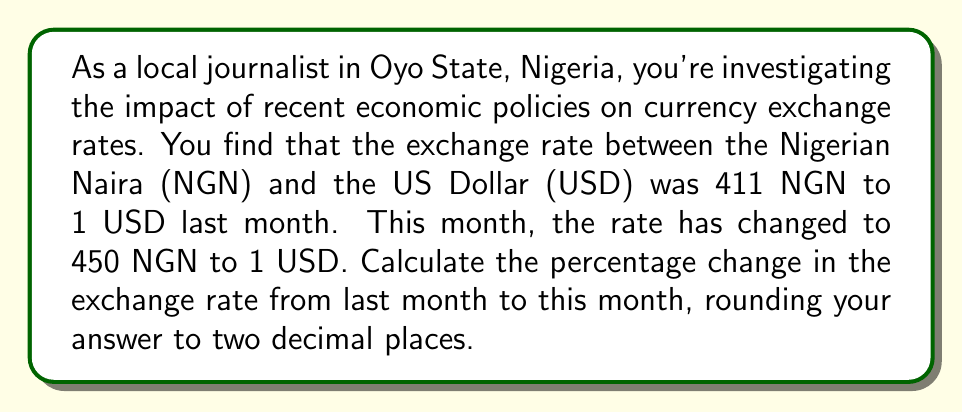Provide a solution to this math problem. To calculate the percentage change in the exchange rate, we need to follow these steps:

1. Identify the initial and final values:
   Initial value (last month): 411 NGN/USD
   Final value (this month): 450 NGN/USD

2. Calculate the difference between the final and initial values:
   $\text{Difference} = \text{Final value} - \text{Initial value}$
   $\text{Difference} = 450 - 411 = 39$

3. Divide the difference by the initial value:
   $\frac{\text{Difference}}{\text{Initial value}} = \frac{39}{411} \approx 0.0948905109$

4. Multiply the result by 100 to express it as a percentage:
   $0.0948905109 \times 100 \approx 9.48905109\%$

5. Round the result to two decimal places:
   $9.49\%$

The formula for percentage change can be expressed as:

$$\text{Percentage Change} = \frac{\text{Final value} - \text{Initial value}}{\text{Initial value}} \times 100\%$$

Plugging in our values:

$$\text{Percentage Change} = \frac{450 - 411}{411} \times 100\% \approx 9.49\%$$

This positive percentage change indicates an increase in the exchange rate, meaning more Naira are required to purchase one US Dollar. This represents a depreciation of the Nigerian Naira against the US Dollar.
Answer: The percentage change in the exchange rate from last month to this month is $9.49\%$. 